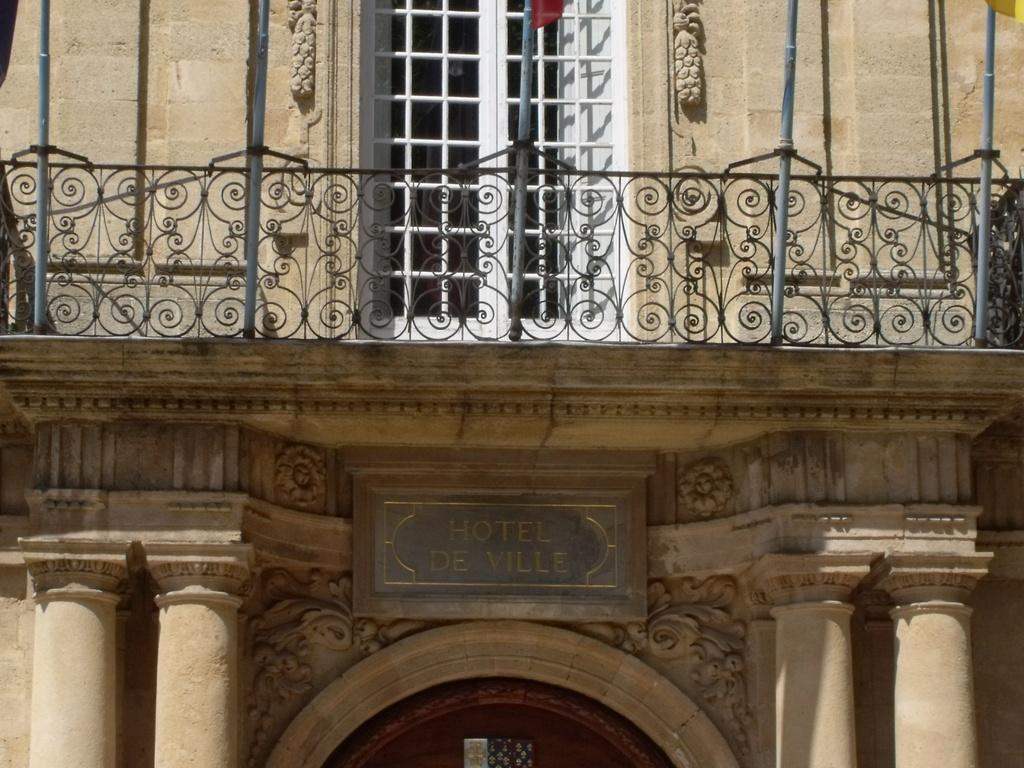In one or two sentences, can you explain what this image depicts? In this image, we can see a building and there are some flags. 